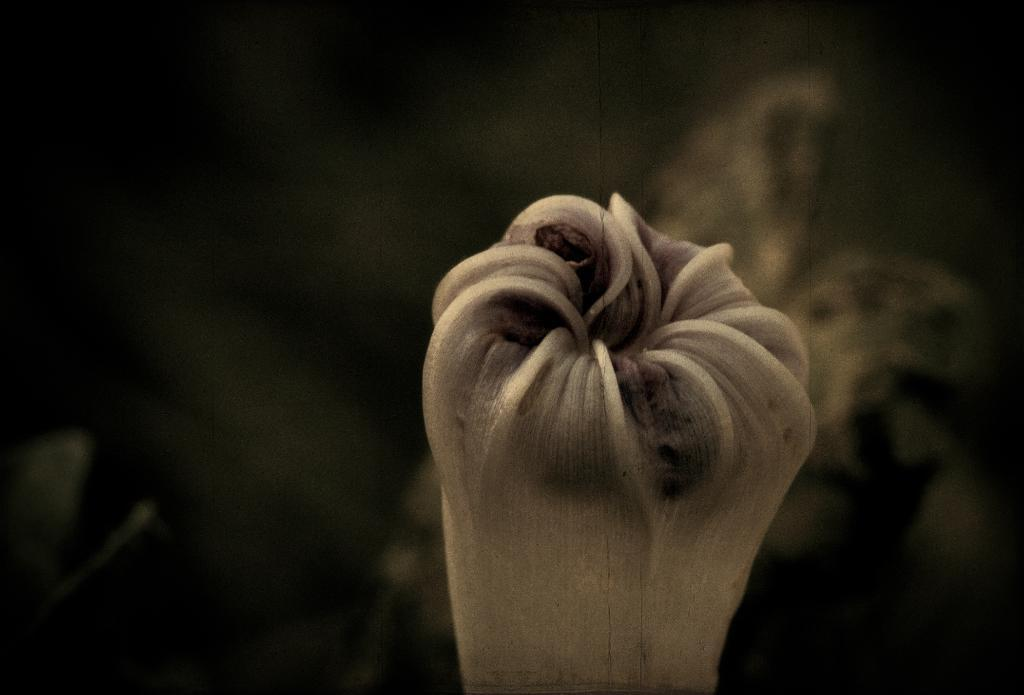What is the main subject of the image? The main subject of the image is a bud. Can you describe the state of the bud in the image? The bud is not yet in full bloom. What can be observed about the background of the image? The background of the image is blurred. What type of coat is the lawyer wearing in the image? There is no lawyer or coat present in the image; it features a bud that is not yet in full bloom with a blurred background. 